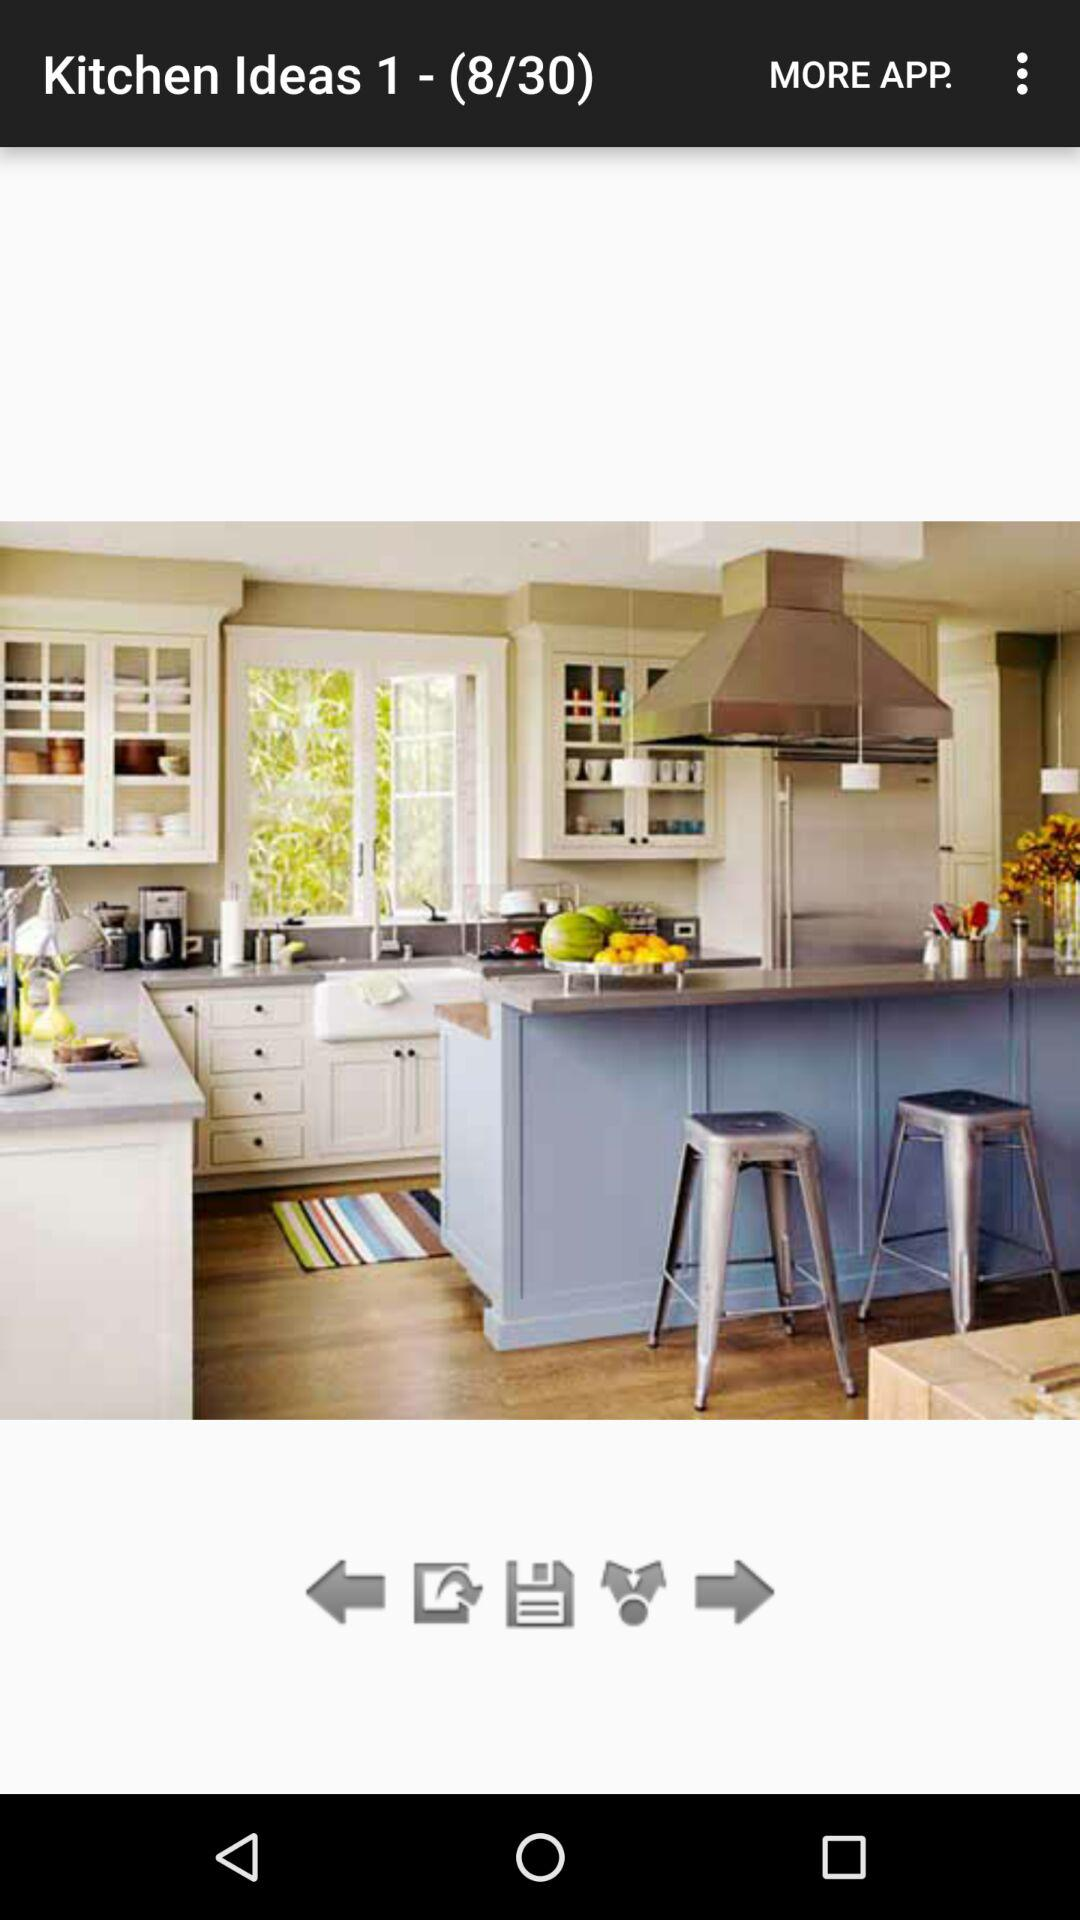What is the total count of "Kitchen Ideas"? The total count of "Kitchen Ideas" is 30. 